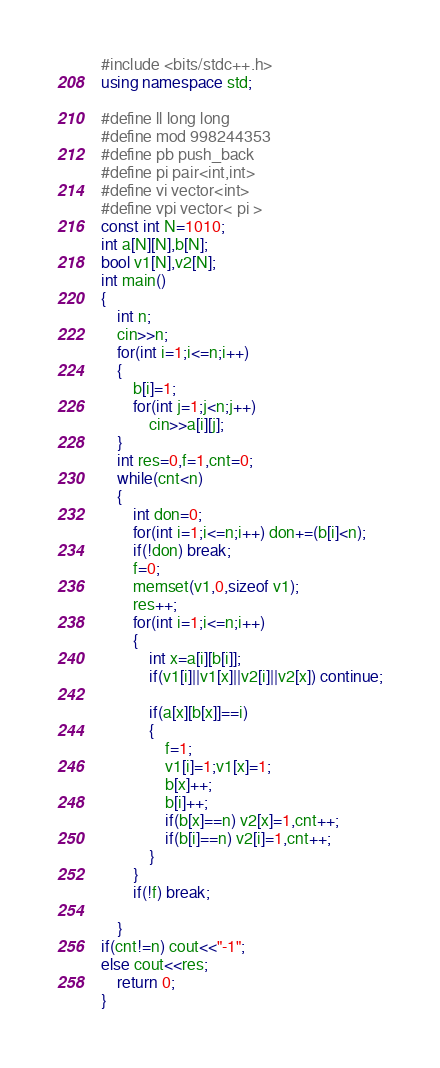Convert code to text. <code><loc_0><loc_0><loc_500><loc_500><_C++_>#include <bits/stdc++.h>
using namespace std;
 
#define ll long long
#define mod 998244353
#define pb push_back
#define pi pair<int,int>
#define vi vector<int>
#define vpi vector< pi > 
const int N=1010;
int a[N][N],b[N];
bool v1[N],v2[N];
int main()
{
	int n;
	cin>>n;
	for(int i=1;i<=n;i++)
	{
		b[i]=1;
		for(int j=1;j<n;j++)
			cin>>a[i][j];
	}
	int res=0,f=1,cnt=0;
	while(cnt<n)
	{
		int don=0;
		for(int i=1;i<=n;i++) don+=(b[i]<n);
		if(!don) break;
		f=0;
		memset(v1,0,sizeof v1);
		res++;
		for(int i=1;i<=n;i++)
		{
			int x=a[i][b[i]];
			if(v1[i]||v1[x]||v2[i]||v2[x]) continue;

			if(a[x][b[x]]==i)
			{
				f=1;
				v1[i]=1;v1[x]=1;
				b[x]++;
				b[i]++;
				if(b[x]==n) v2[x]=1,cnt++;
				if(b[i]==n) v2[i]=1,cnt++;
			}
		}
		if(!f) break;

	}
if(cnt!=n) cout<<"-1";
else cout<<res;
	return 0;
}</code> 